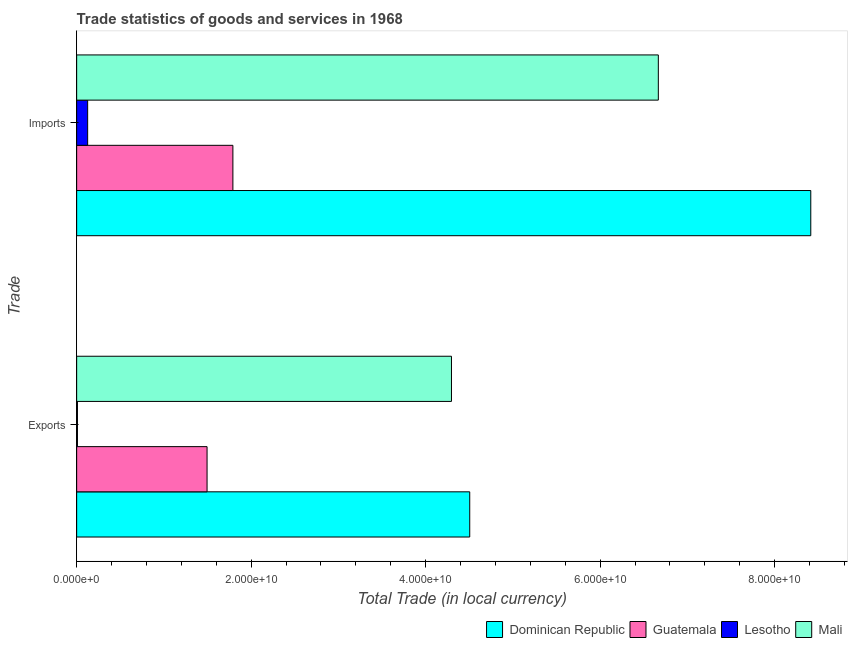How many different coloured bars are there?
Your answer should be compact. 4. How many groups of bars are there?
Your answer should be compact. 2. Are the number of bars per tick equal to the number of legend labels?
Give a very brief answer. Yes. How many bars are there on the 1st tick from the top?
Your response must be concise. 4. How many bars are there on the 2nd tick from the bottom?
Your answer should be very brief. 4. What is the label of the 2nd group of bars from the top?
Provide a short and direct response. Exports. What is the export of goods and services in Lesotho?
Offer a very short reply. 9.03e+07. Across all countries, what is the maximum imports of goods and services?
Your answer should be very brief. 8.41e+1. Across all countries, what is the minimum export of goods and services?
Provide a short and direct response. 9.03e+07. In which country was the export of goods and services maximum?
Provide a succinct answer. Dominican Republic. In which country was the imports of goods and services minimum?
Provide a short and direct response. Lesotho. What is the total imports of goods and services in the graph?
Provide a short and direct response. 1.70e+11. What is the difference between the export of goods and services in Guatemala and that in Mali?
Your answer should be compact. -2.80e+1. What is the difference between the export of goods and services in Dominican Republic and the imports of goods and services in Guatemala?
Make the answer very short. 2.71e+1. What is the average imports of goods and services per country?
Your response must be concise. 4.25e+1. What is the difference between the imports of goods and services and export of goods and services in Lesotho?
Keep it short and to the point. 1.17e+09. What is the ratio of the imports of goods and services in Guatemala to that in Dominican Republic?
Ensure brevity in your answer.  0.21. What does the 3rd bar from the top in Exports represents?
Keep it short and to the point. Guatemala. What does the 4th bar from the bottom in Exports represents?
Your response must be concise. Mali. How many bars are there?
Offer a terse response. 8. Are all the bars in the graph horizontal?
Your response must be concise. Yes. How many countries are there in the graph?
Ensure brevity in your answer.  4. What is the difference between two consecutive major ticks on the X-axis?
Ensure brevity in your answer.  2.00e+1. Are the values on the major ticks of X-axis written in scientific E-notation?
Give a very brief answer. Yes. Does the graph contain grids?
Ensure brevity in your answer.  No. Where does the legend appear in the graph?
Keep it short and to the point. Bottom right. How are the legend labels stacked?
Make the answer very short. Horizontal. What is the title of the graph?
Offer a terse response. Trade statistics of goods and services in 1968. Does "Bhutan" appear as one of the legend labels in the graph?
Provide a succinct answer. No. What is the label or title of the X-axis?
Your answer should be very brief. Total Trade (in local currency). What is the label or title of the Y-axis?
Give a very brief answer. Trade. What is the Total Trade (in local currency) of Dominican Republic in Exports?
Offer a very short reply. 4.50e+1. What is the Total Trade (in local currency) in Guatemala in Exports?
Your answer should be compact. 1.49e+1. What is the Total Trade (in local currency) of Lesotho in Exports?
Ensure brevity in your answer.  9.03e+07. What is the Total Trade (in local currency) in Mali in Exports?
Your answer should be compact. 4.30e+1. What is the Total Trade (in local currency) in Dominican Republic in Imports?
Your answer should be compact. 8.41e+1. What is the Total Trade (in local currency) in Guatemala in Imports?
Provide a short and direct response. 1.79e+1. What is the Total Trade (in local currency) of Lesotho in Imports?
Offer a terse response. 1.26e+09. What is the Total Trade (in local currency) in Mali in Imports?
Your answer should be very brief. 6.67e+1. Across all Trade, what is the maximum Total Trade (in local currency) in Dominican Republic?
Ensure brevity in your answer.  8.41e+1. Across all Trade, what is the maximum Total Trade (in local currency) in Guatemala?
Give a very brief answer. 1.79e+1. Across all Trade, what is the maximum Total Trade (in local currency) of Lesotho?
Offer a terse response. 1.26e+09. Across all Trade, what is the maximum Total Trade (in local currency) of Mali?
Ensure brevity in your answer.  6.67e+1. Across all Trade, what is the minimum Total Trade (in local currency) in Dominican Republic?
Your answer should be very brief. 4.50e+1. Across all Trade, what is the minimum Total Trade (in local currency) of Guatemala?
Make the answer very short. 1.49e+1. Across all Trade, what is the minimum Total Trade (in local currency) of Lesotho?
Make the answer very short. 9.03e+07. Across all Trade, what is the minimum Total Trade (in local currency) in Mali?
Offer a terse response. 4.30e+1. What is the total Total Trade (in local currency) of Dominican Republic in the graph?
Provide a short and direct response. 1.29e+11. What is the total Total Trade (in local currency) in Guatemala in the graph?
Ensure brevity in your answer.  3.29e+1. What is the total Total Trade (in local currency) of Lesotho in the graph?
Ensure brevity in your answer.  1.35e+09. What is the total Total Trade (in local currency) of Mali in the graph?
Keep it short and to the point. 1.10e+11. What is the difference between the Total Trade (in local currency) of Dominican Republic in Exports and that in Imports?
Keep it short and to the point. -3.91e+1. What is the difference between the Total Trade (in local currency) in Guatemala in Exports and that in Imports?
Offer a terse response. -2.96e+09. What is the difference between the Total Trade (in local currency) of Lesotho in Exports and that in Imports?
Provide a short and direct response. -1.17e+09. What is the difference between the Total Trade (in local currency) in Mali in Exports and that in Imports?
Keep it short and to the point. -2.37e+1. What is the difference between the Total Trade (in local currency) in Dominican Republic in Exports and the Total Trade (in local currency) in Guatemala in Imports?
Your answer should be very brief. 2.71e+1. What is the difference between the Total Trade (in local currency) in Dominican Republic in Exports and the Total Trade (in local currency) in Lesotho in Imports?
Keep it short and to the point. 4.38e+1. What is the difference between the Total Trade (in local currency) of Dominican Republic in Exports and the Total Trade (in local currency) of Mali in Imports?
Provide a succinct answer. -2.16e+1. What is the difference between the Total Trade (in local currency) in Guatemala in Exports and the Total Trade (in local currency) in Lesotho in Imports?
Offer a terse response. 1.37e+1. What is the difference between the Total Trade (in local currency) in Guatemala in Exports and the Total Trade (in local currency) in Mali in Imports?
Give a very brief answer. -5.17e+1. What is the difference between the Total Trade (in local currency) in Lesotho in Exports and the Total Trade (in local currency) in Mali in Imports?
Offer a very short reply. -6.66e+1. What is the average Total Trade (in local currency) of Dominican Republic per Trade?
Provide a succinct answer. 6.46e+1. What is the average Total Trade (in local currency) in Guatemala per Trade?
Ensure brevity in your answer.  1.64e+1. What is the average Total Trade (in local currency) in Lesotho per Trade?
Offer a terse response. 6.75e+08. What is the average Total Trade (in local currency) of Mali per Trade?
Provide a short and direct response. 5.48e+1. What is the difference between the Total Trade (in local currency) in Dominican Republic and Total Trade (in local currency) in Guatemala in Exports?
Provide a succinct answer. 3.01e+1. What is the difference between the Total Trade (in local currency) of Dominican Republic and Total Trade (in local currency) of Lesotho in Exports?
Offer a very short reply. 4.50e+1. What is the difference between the Total Trade (in local currency) in Dominican Republic and Total Trade (in local currency) in Mali in Exports?
Make the answer very short. 2.09e+09. What is the difference between the Total Trade (in local currency) of Guatemala and Total Trade (in local currency) of Lesotho in Exports?
Your answer should be compact. 1.49e+1. What is the difference between the Total Trade (in local currency) of Guatemala and Total Trade (in local currency) of Mali in Exports?
Provide a short and direct response. -2.80e+1. What is the difference between the Total Trade (in local currency) in Lesotho and Total Trade (in local currency) in Mali in Exports?
Offer a very short reply. -4.29e+1. What is the difference between the Total Trade (in local currency) in Dominican Republic and Total Trade (in local currency) in Guatemala in Imports?
Your answer should be compact. 6.62e+1. What is the difference between the Total Trade (in local currency) in Dominican Republic and Total Trade (in local currency) in Lesotho in Imports?
Provide a short and direct response. 8.29e+1. What is the difference between the Total Trade (in local currency) of Dominican Republic and Total Trade (in local currency) of Mali in Imports?
Offer a terse response. 1.75e+1. What is the difference between the Total Trade (in local currency) in Guatemala and Total Trade (in local currency) in Lesotho in Imports?
Provide a short and direct response. 1.66e+1. What is the difference between the Total Trade (in local currency) in Guatemala and Total Trade (in local currency) in Mali in Imports?
Give a very brief answer. -4.88e+1. What is the difference between the Total Trade (in local currency) in Lesotho and Total Trade (in local currency) in Mali in Imports?
Your answer should be very brief. -6.54e+1. What is the ratio of the Total Trade (in local currency) in Dominican Republic in Exports to that in Imports?
Your answer should be very brief. 0.54. What is the ratio of the Total Trade (in local currency) in Guatemala in Exports to that in Imports?
Your response must be concise. 0.83. What is the ratio of the Total Trade (in local currency) in Lesotho in Exports to that in Imports?
Give a very brief answer. 0.07. What is the ratio of the Total Trade (in local currency) in Mali in Exports to that in Imports?
Make the answer very short. 0.64. What is the difference between the highest and the second highest Total Trade (in local currency) of Dominican Republic?
Your response must be concise. 3.91e+1. What is the difference between the highest and the second highest Total Trade (in local currency) in Guatemala?
Your answer should be very brief. 2.96e+09. What is the difference between the highest and the second highest Total Trade (in local currency) in Lesotho?
Make the answer very short. 1.17e+09. What is the difference between the highest and the second highest Total Trade (in local currency) of Mali?
Make the answer very short. 2.37e+1. What is the difference between the highest and the lowest Total Trade (in local currency) in Dominican Republic?
Offer a very short reply. 3.91e+1. What is the difference between the highest and the lowest Total Trade (in local currency) in Guatemala?
Provide a succinct answer. 2.96e+09. What is the difference between the highest and the lowest Total Trade (in local currency) in Lesotho?
Your answer should be compact. 1.17e+09. What is the difference between the highest and the lowest Total Trade (in local currency) of Mali?
Make the answer very short. 2.37e+1. 